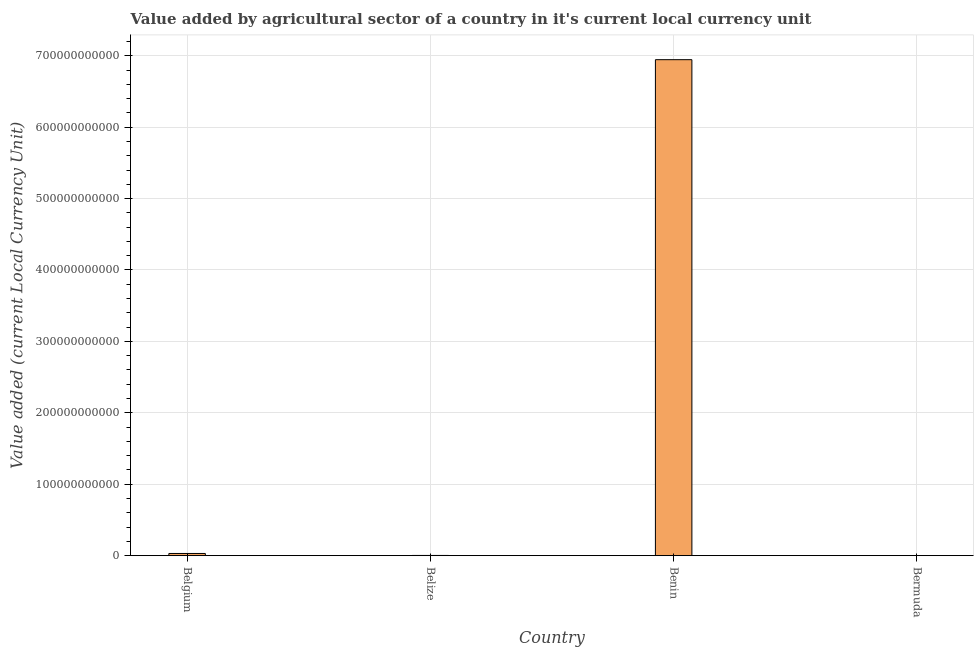What is the title of the graph?
Offer a terse response. Value added by agricultural sector of a country in it's current local currency unit. What is the label or title of the X-axis?
Ensure brevity in your answer.  Country. What is the label or title of the Y-axis?
Your response must be concise. Value added (current Local Currency Unit). What is the value added by agriculture sector in Bermuda?
Keep it short and to the point. 4.52e+07. Across all countries, what is the maximum value added by agriculture sector?
Give a very brief answer. 6.94e+11. Across all countries, what is the minimum value added by agriculture sector?
Provide a succinct answer. 4.52e+07. In which country was the value added by agriculture sector maximum?
Give a very brief answer. Benin. In which country was the value added by agriculture sector minimum?
Give a very brief answer. Bermuda. What is the sum of the value added by agriculture sector?
Your answer should be very brief. 6.98e+11. What is the difference between the value added by agriculture sector in Belize and Benin?
Provide a succinct answer. -6.94e+11. What is the average value added by agriculture sector per country?
Your response must be concise. 1.74e+11. What is the median value added by agriculture sector?
Offer a very short reply. 1.67e+09. In how many countries, is the value added by agriculture sector greater than 480000000000 LCU?
Make the answer very short. 1. What is the ratio of the value added by agriculture sector in Belgium to that in Bermuda?
Your response must be concise. 67.43. Is the value added by agriculture sector in Belize less than that in Bermuda?
Provide a succinct answer. No. What is the difference between the highest and the second highest value added by agriculture sector?
Keep it short and to the point. 6.91e+11. Is the sum of the value added by agriculture sector in Belgium and Bermuda greater than the maximum value added by agriculture sector across all countries?
Your answer should be compact. No. What is the difference between the highest and the lowest value added by agriculture sector?
Keep it short and to the point. 6.94e+11. How many bars are there?
Provide a succinct answer. 4. What is the difference between two consecutive major ticks on the Y-axis?
Keep it short and to the point. 1.00e+11. What is the Value added (current Local Currency Unit) of Belgium?
Provide a succinct answer. 3.05e+09. What is the Value added (current Local Currency Unit) in Belize?
Your response must be concise. 2.98e+08. What is the Value added (current Local Currency Unit) in Benin?
Your response must be concise. 6.94e+11. What is the Value added (current Local Currency Unit) of Bermuda?
Your answer should be compact. 4.52e+07. What is the difference between the Value added (current Local Currency Unit) in Belgium and Belize?
Give a very brief answer. 2.75e+09. What is the difference between the Value added (current Local Currency Unit) in Belgium and Benin?
Your answer should be compact. -6.91e+11. What is the difference between the Value added (current Local Currency Unit) in Belgium and Bermuda?
Offer a terse response. 3.01e+09. What is the difference between the Value added (current Local Currency Unit) in Belize and Benin?
Keep it short and to the point. -6.94e+11. What is the difference between the Value added (current Local Currency Unit) in Belize and Bermuda?
Ensure brevity in your answer.  2.52e+08. What is the difference between the Value added (current Local Currency Unit) in Benin and Bermuda?
Make the answer very short. 6.94e+11. What is the ratio of the Value added (current Local Currency Unit) in Belgium to that in Belize?
Make the answer very short. 10.25. What is the ratio of the Value added (current Local Currency Unit) in Belgium to that in Benin?
Offer a terse response. 0. What is the ratio of the Value added (current Local Currency Unit) in Belgium to that in Bermuda?
Keep it short and to the point. 67.43. What is the ratio of the Value added (current Local Currency Unit) in Belize to that in Bermuda?
Offer a terse response. 6.58. What is the ratio of the Value added (current Local Currency Unit) in Benin to that in Bermuda?
Offer a very short reply. 1.53e+04. 